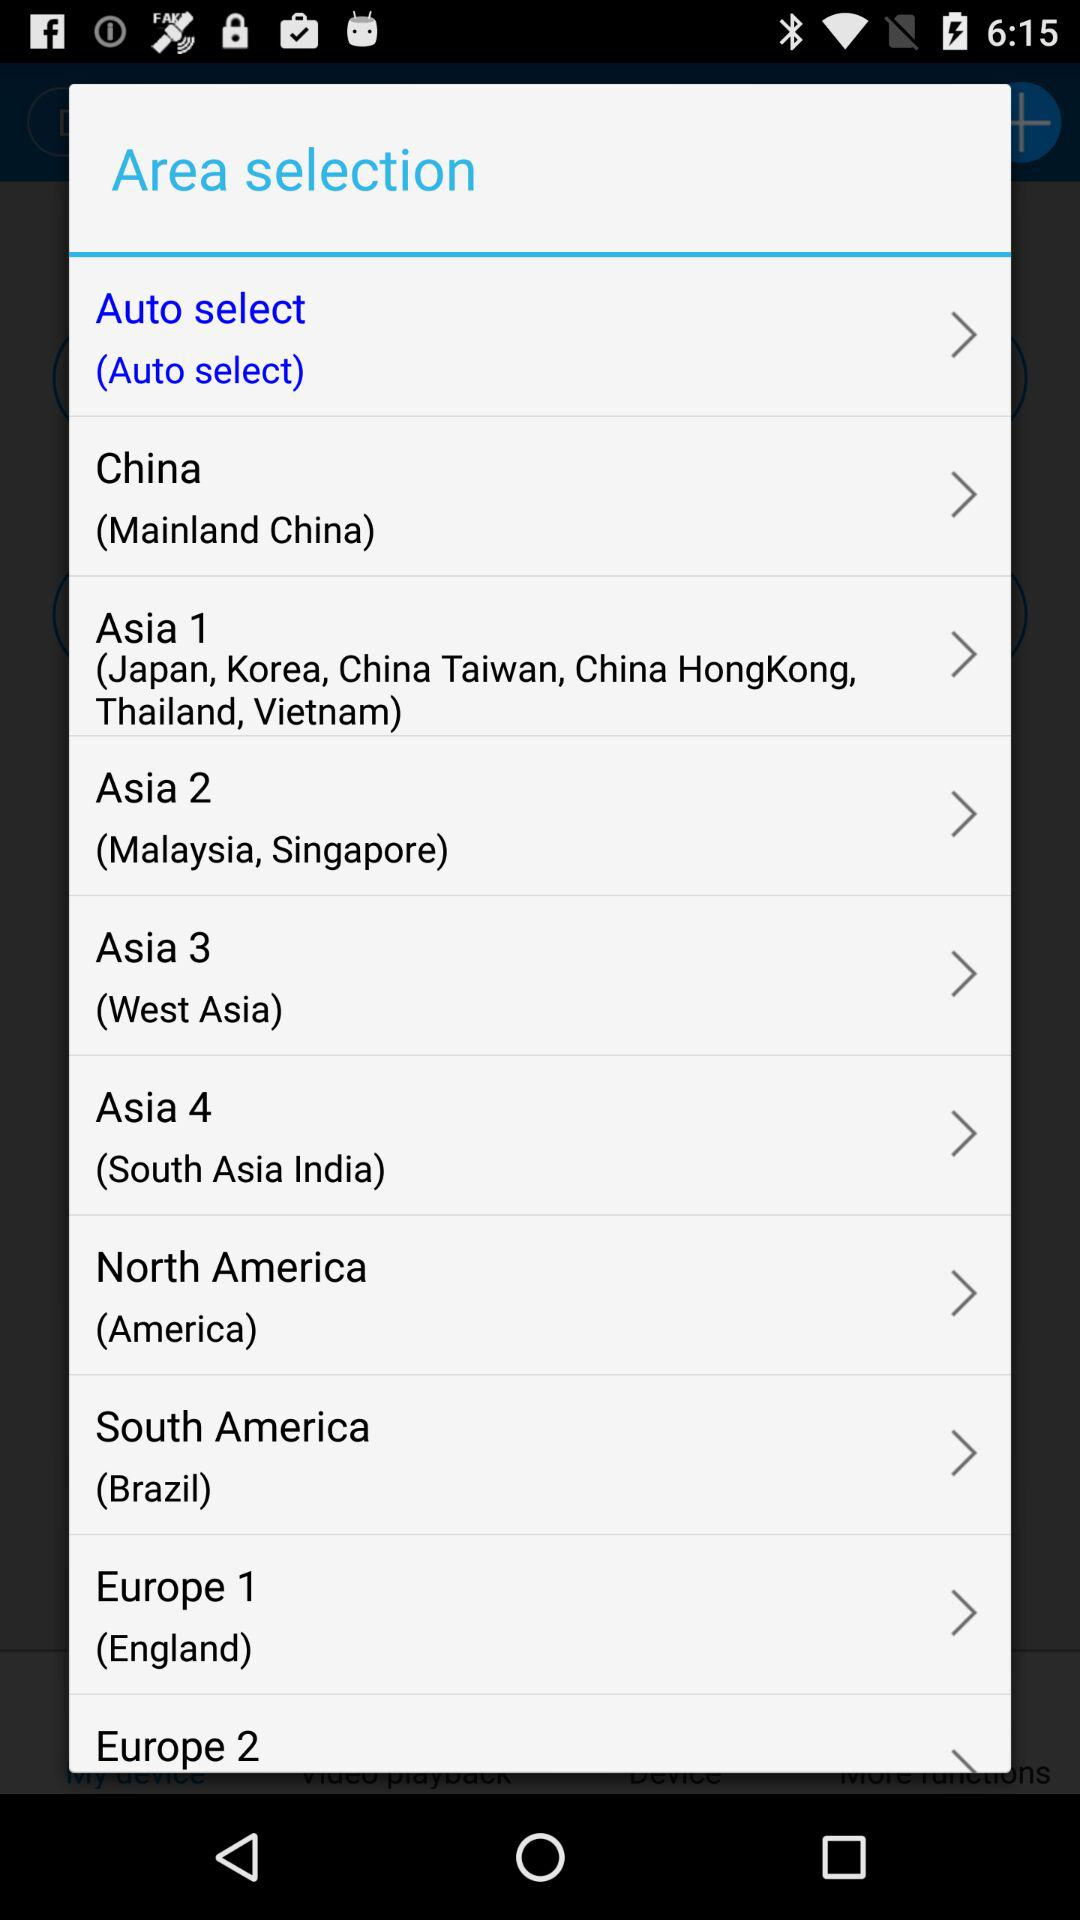How many regions are in the Asia section?
Answer the question using a single word or phrase. 4 